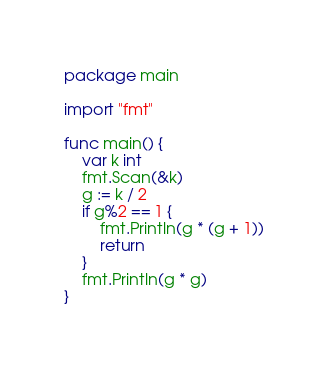Convert code to text. <code><loc_0><loc_0><loc_500><loc_500><_Go_>package main

import "fmt"

func main() {
	var k int
	fmt.Scan(&k)
	g := k / 2
	if g%2 == 1 {
		fmt.Println(g * (g + 1))
		return
	}
	fmt.Println(g * g)
}
</code> 